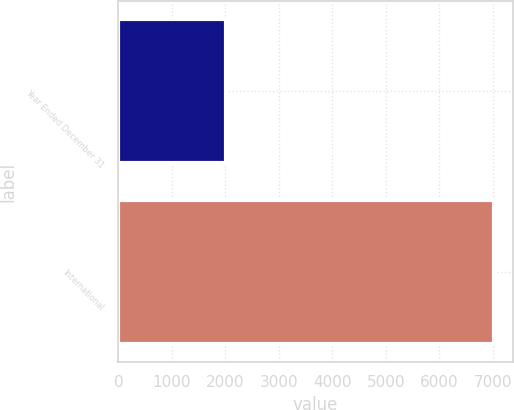Convert chart. <chart><loc_0><loc_0><loc_500><loc_500><bar_chart><fcel>Year Ended December 31<fcel>International<nl><fcel>2010<fcel>7019<nl></chart> 